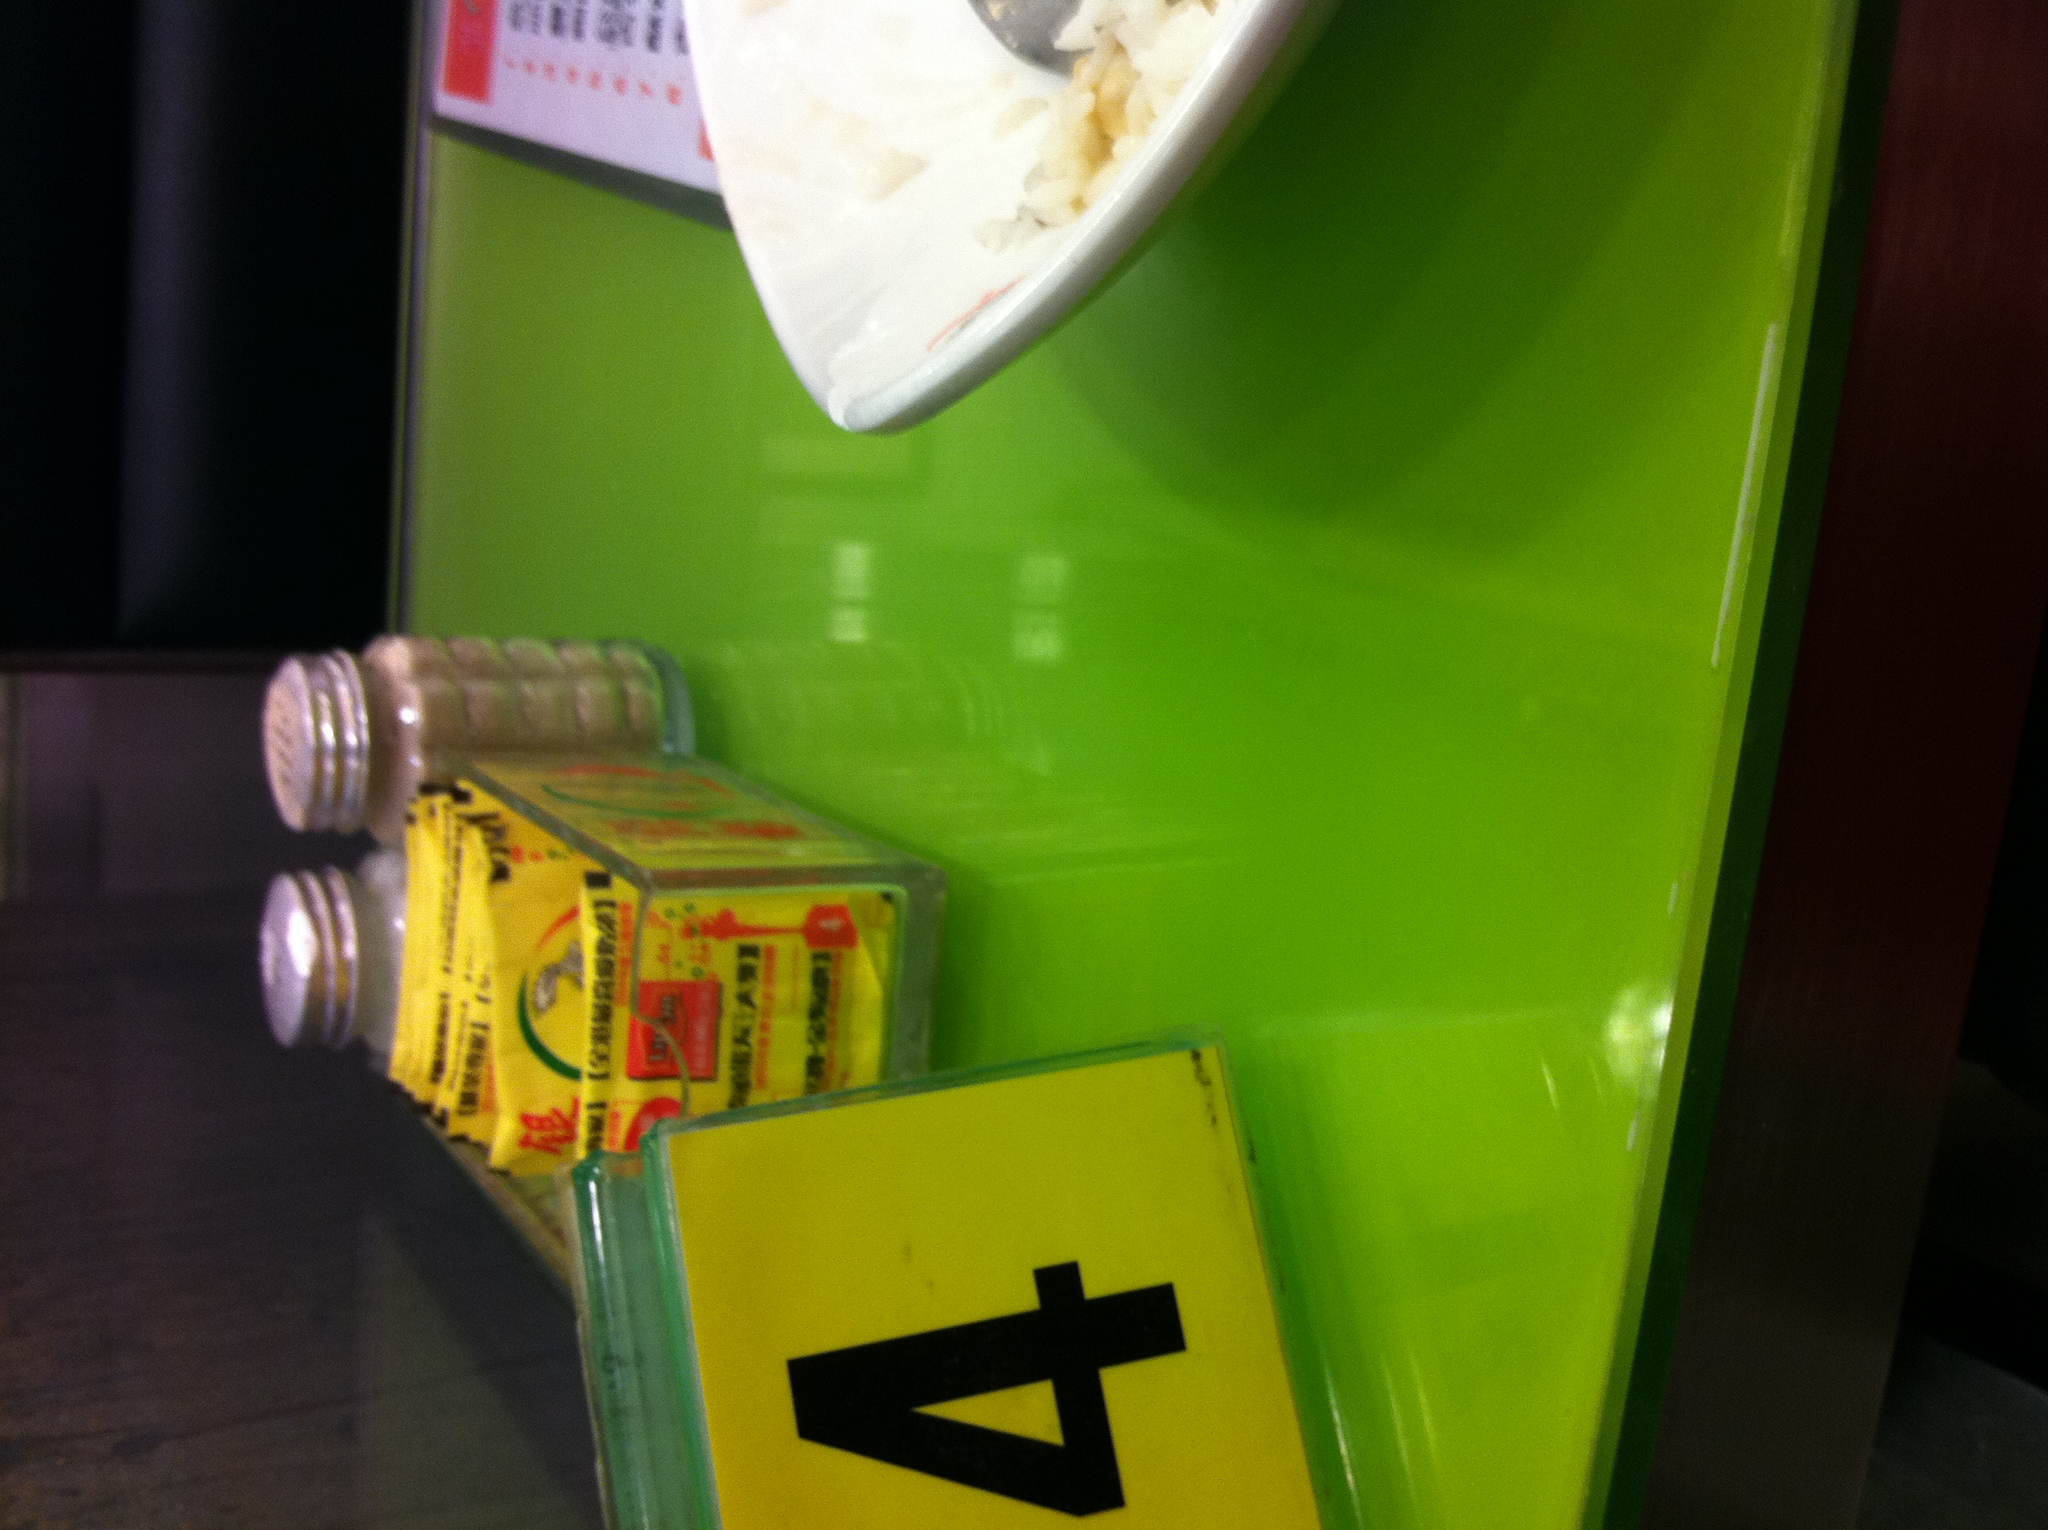What items can you see on the table apart from the table number? In addition to the table number, I can see a bowl of rice, a pair of salt, and pepper shakers, and a carton that seems to contain some sort of seasoning packets. 